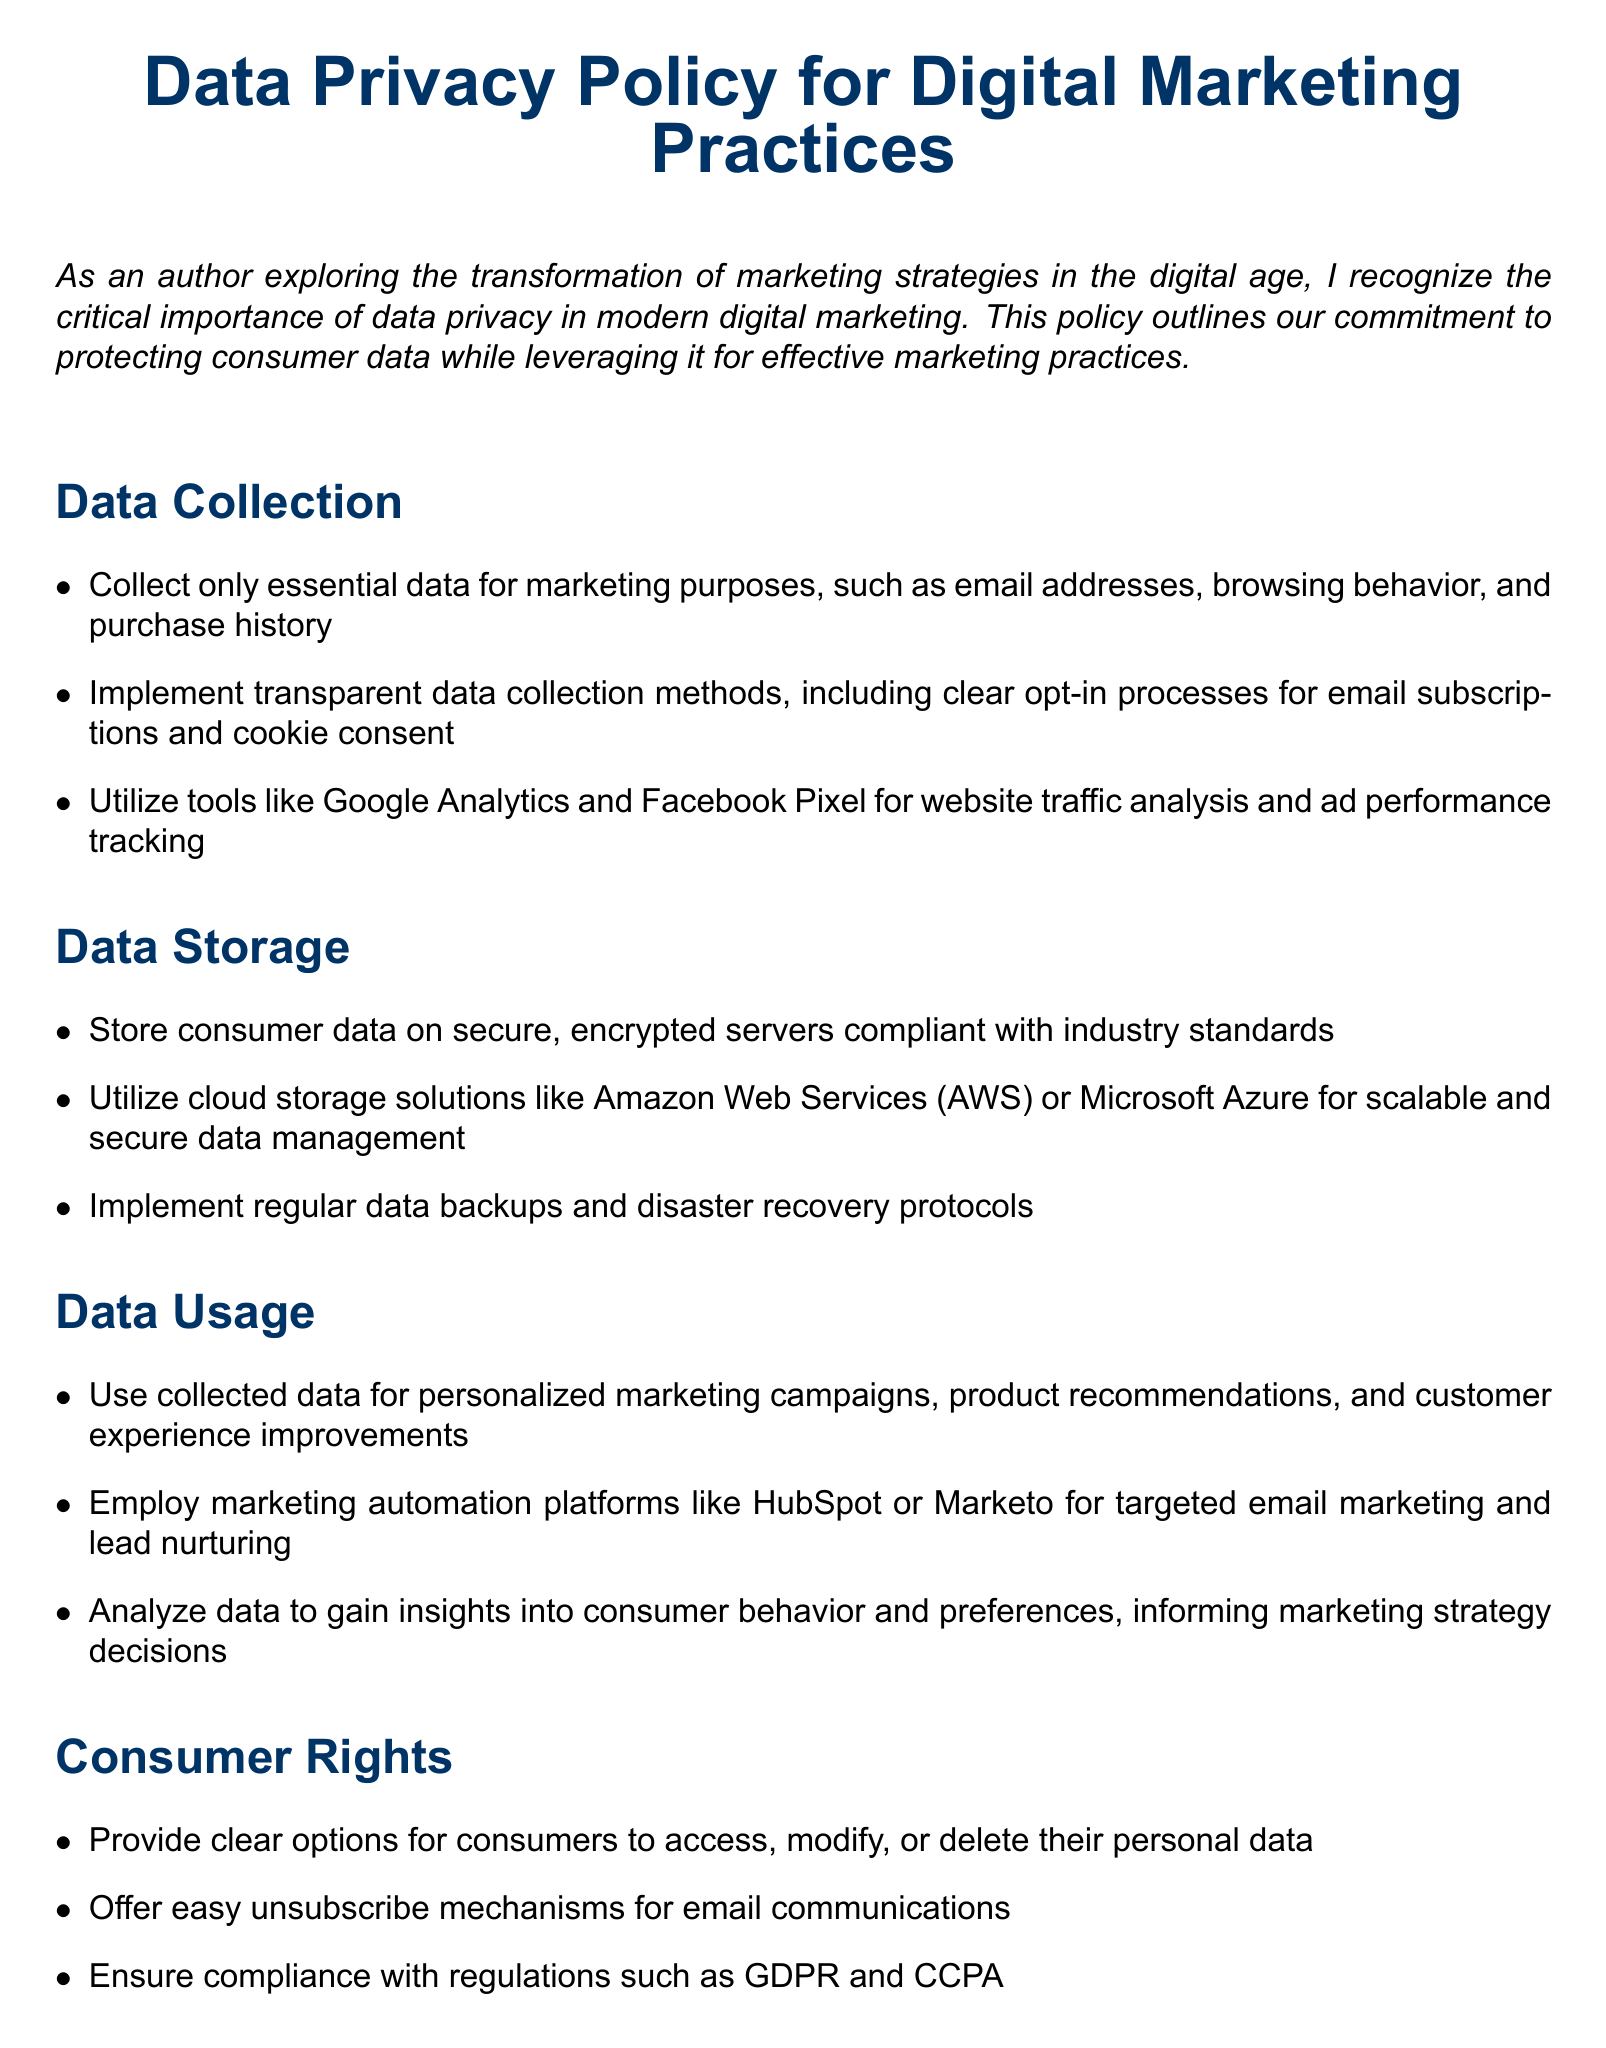What is the primary focus of the policy? The document outlines the importance of data privacy in digital marketing practices, stating the commitment to protecting consumer data.
Answer: Data privacy What types of consumer data are collected? The policy specifies that essential data for marketing includes email addresses, browsing behavior, and purchase history.
Answer: Email addresses, browsing behavior, and purchase history What compliance regulations are mentioned? The document states that the policy ensures compliance with regulations such as GDPR and CCPA.
Answer: GDPR and CCPA What storage solutions are recommended? The document recommends using cloud storage solutions like Amazon Web Services or Microsoft Azure for data management.
Answer: Amazon Web Services or Microsoft Azure How often will the policy be reviewed? The policy indicates that it will be reviewed and updated annually.
Answer: Annually What mechanism is provided for consumers to unsubscribe? The policy specifies that there should be easy unsubscribe mechanisms for email communications.
Answer: Easy unsubscribe mechanisms What training is provided for employees? The document mentions providing data privacy training for employees who handle consumer information.
Answer: Data privacy training What measures are suggested for data protection? The document lists cybersecurity measures, including firewalls and multi-factor authentication.
Answer: Firewalls and multi-factor authentication What tools are suggested for data analysis? The policy suggests using marketing automation platforms like HubSpot or Marketo for targeted marketing efforts.
Answer: HubSpot or Marketo 